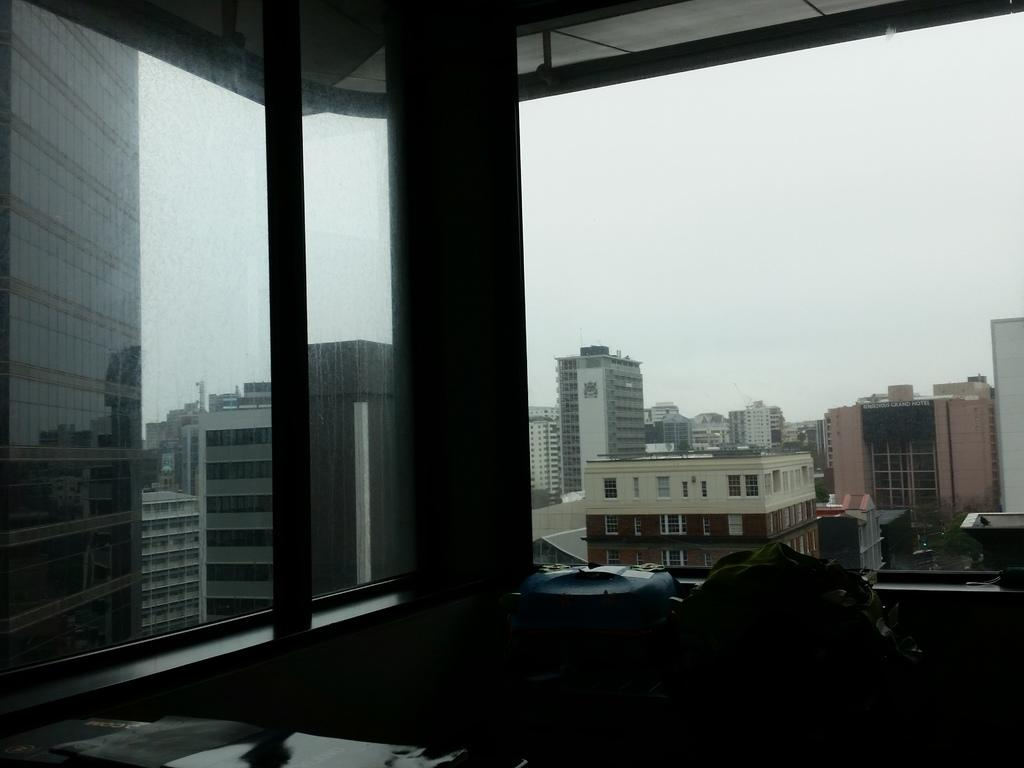What objects are placed on the window in the image? There are glasses on the window in the image. What can be seen through the window? Buildings are visible through the window. Is there any vegetation present in the image? There might be a plant in the image. How would you describe the weather based on the image? The sky appears to be cloudy in the image. What type of quill is being used to write on the glass in the image? There is no quill or writing on the glass in the image. What flavors of juice can be seen in the glasses in the image? There is no juice present in the image; there are glasses on the window. 